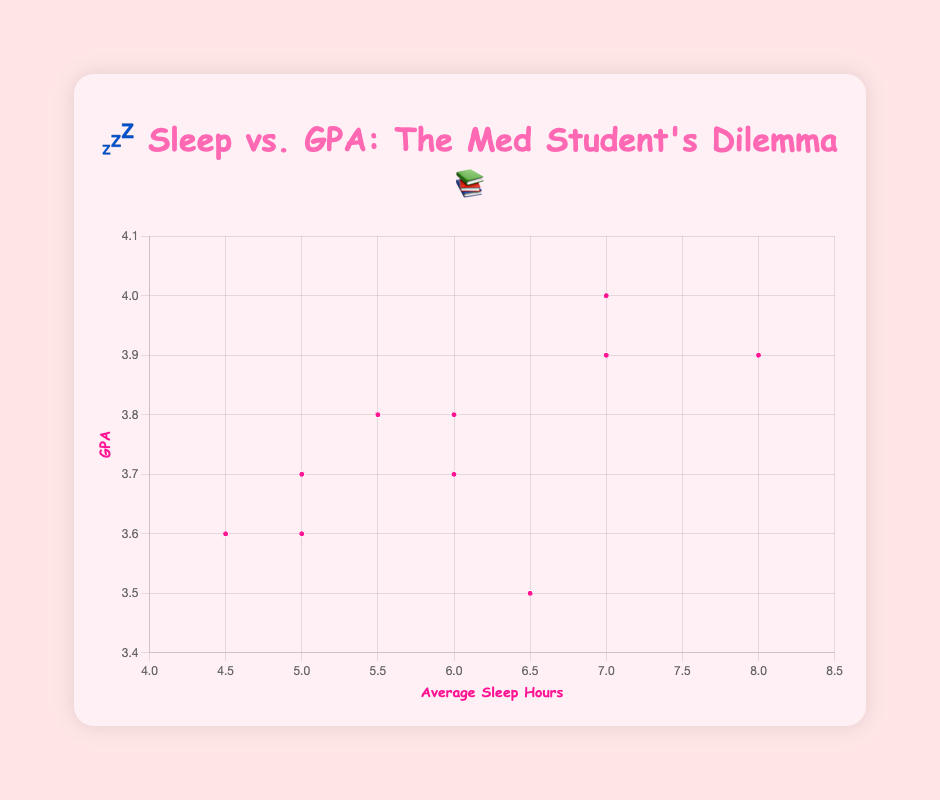How many students sleep 7 hours per night? Identify the points on the plot corresponding to 7 hours of sleep. There are two such points: one at the GPA 3.9 and the other at 4.0.
Answer: 2 Who sleeps the most hours on average and what is their GPA? Look for the point with the highest value on the x-axis, which is 8 hours. The corresponding GPA for this point is 3.9.
Answer: Sophia Martinez, GPA 3.9 What is the relationship between sleep hours and GPA in general? Observe the trend of points on the plot. Generally, GPAs tend to increase with more sleep hours, with a few exceptions.
Answer: Positive correlation Which student has the lowest GPA and how many hours do they sleep? Identify the point with the lowest value on the y-axis, which is the GPA of 3.5. The corresponding sleep hours for this point is 6.5 hours.
Answer: Rachel Adams, 6.5 hours Find the range of sleep hours for students with GPAs between 3.7 and 3.9. Locate the points on the plot with GPAs between 3.7 and 3.9 (inclusive). These points' sleep hours range from 5 to 8 hours.
Answer: 5 to 8 hours If a student sleeps 6 hours per night, what range of GPAs can they expect based on this data? Identify the points on the plot corresponding to 6 hours of sleep. These points have GPAs of 3.7 and 3.8.
Answer: 3.7 to 3.8 Compare the GPA variance for students who sleep less than 5 hours versus those who sleep between 7 and 8 hours. For sleep < 5 hours: Only 4.5 hours appears with GPA = 3.6.
For sleep 7-8 hours: GPAs range from 3.9 to 4.0. The GPA variance is thus higher for those who sleep between 7 and 8 hours.
Answer: Higher variance for 7-8 hours What pattern can you observe in students who get 5 hours of sleep? Locate all points for 5 hours of sleep. The GPAs for these points are 3.6, 3.7, and 3.8. This shows a slight upward trend in GPA with 5 hours of sleep.
Answer: Slight upward trend Who has the same sleep hours as Anne Laverty and what is their GPA? Anne Laverty has an average sleep of 6 hours. Identify the other point at 6 hours, which corresponds to a GPA of 3.8.
Answer: Laura Scott, 3.8 Does anyone with 6.5 hours of sleep have a higher GPA than Rachel Adams? Rachel Adams, who sleeps 6.5 hours, has a GPA of 3.5. No one else is recorded with 6.5 hours of sleep for comparison.
Answer: No 